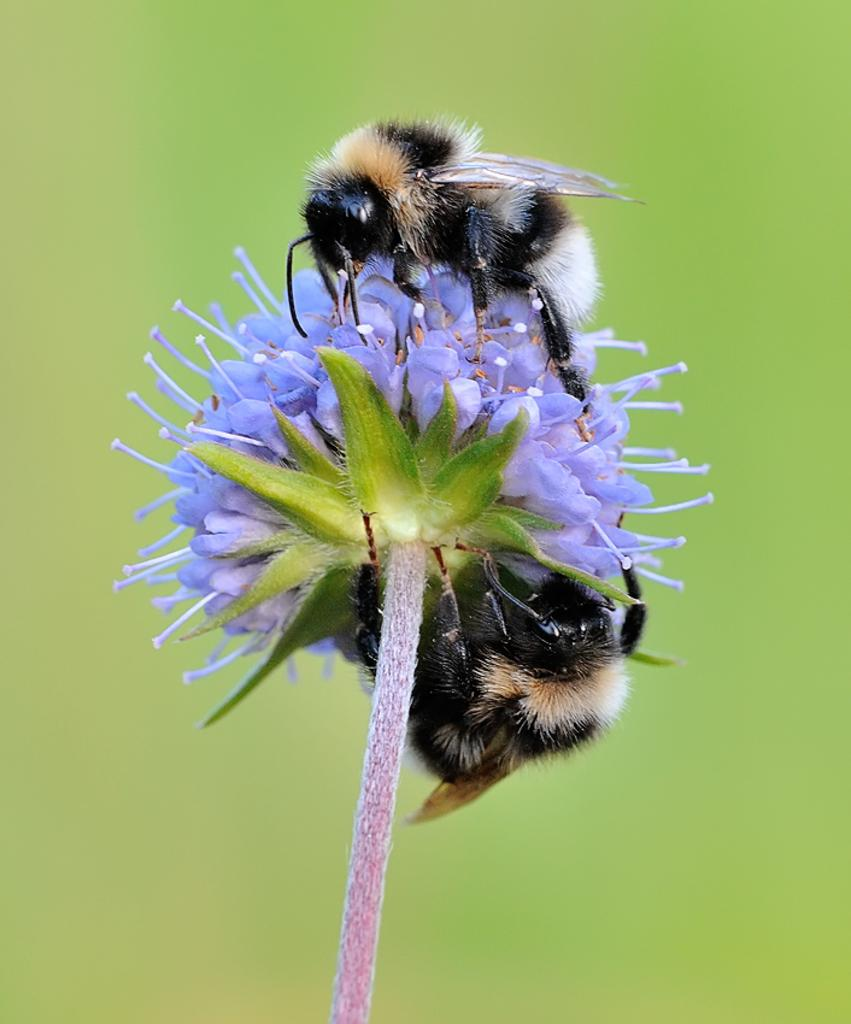What type of living organisms can be seen on the flower in the image? There are insects on a flower in the image. What type of jam is being used to extinguish the flame on the flower in the image? There is no jam or flame present in the image; it features insects on a flower. 